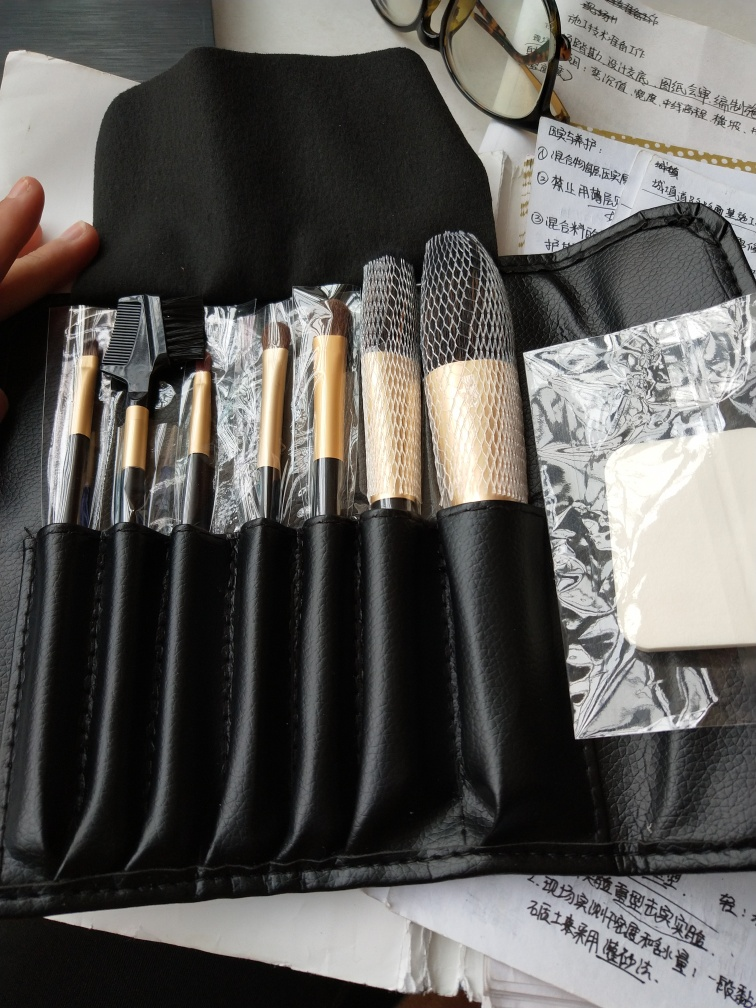What can you infer about the person who owns these items? Based on the presence of the makeup brushes and the roll-up case, it's likely that the owner has an interest in makeup, possibly as a professional makeup artist or an enthusiast. The neat arrangement of the brushes suggests the owner values organization. Furthermore, the inclusion of a spectacle case may indicate that the owner wears glasses. 